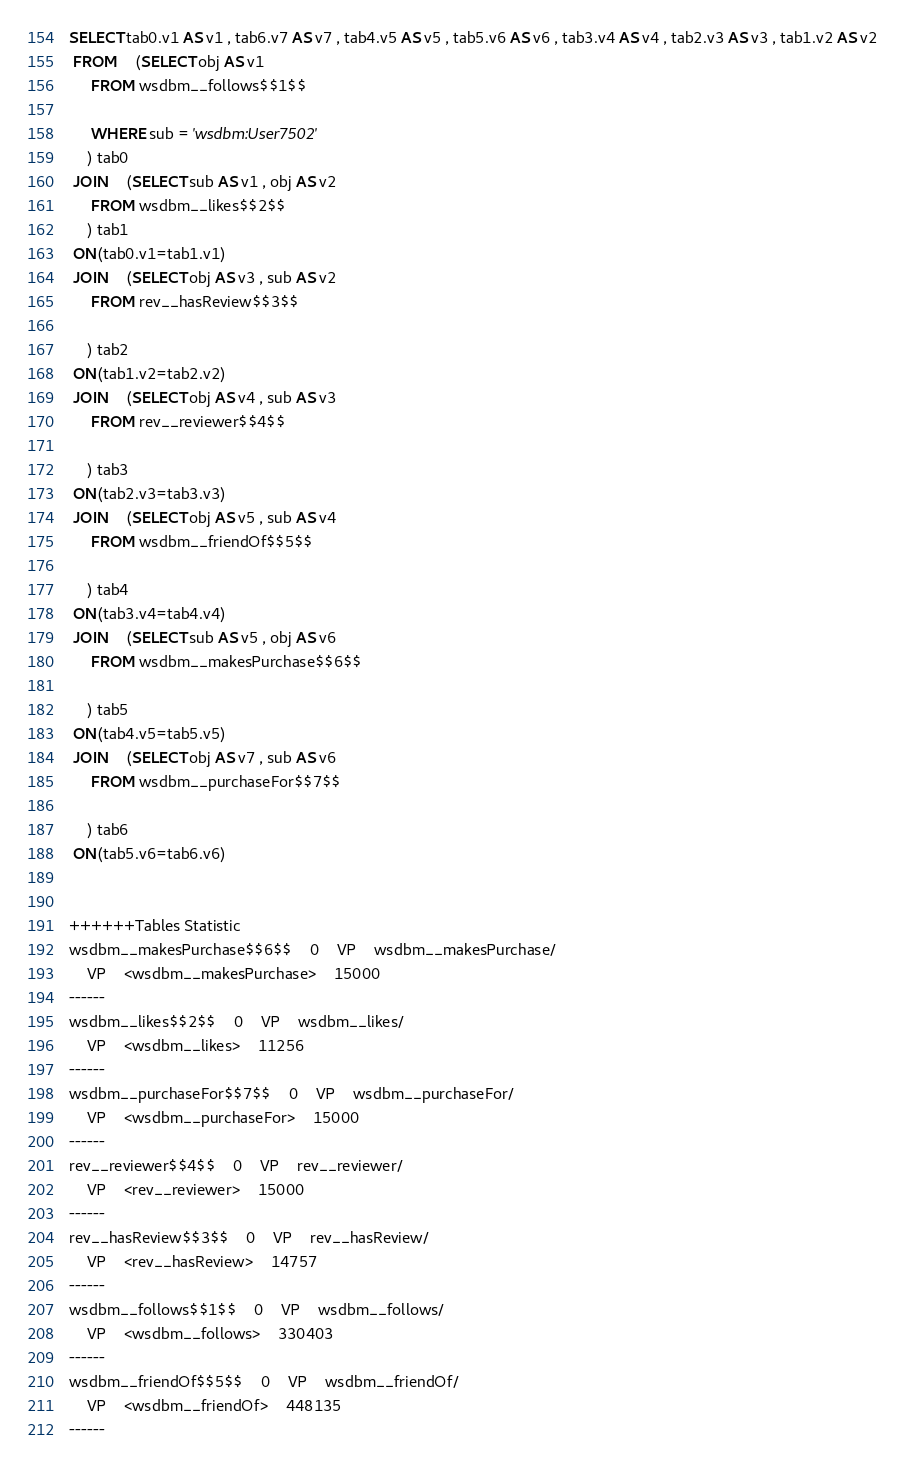Convert code to text. <code><loc_0><loc_0><loc_500><loc_500><_SQL_>SELECT tab0.v1 AS v1 , tab6.v7 AS v7 , tab4.v5 AS v5 , tab5.v6 AS v6 , tab3.v4 AS v4 , tab2.v3 AS v3 , tab1.v2 AS v2 
 FROM    (SELECT obj AS v1 
	 FROM wsdbm__follows$$1$$
	 
	 WHERE sub = 'wsdbm:User7502'
	) tab0
 JOIN    (SELECT sub AS v1 , obj AS v2 
	 FROM wsdbm__likes$$2$$
	) tab1
 ON(tab0.v1=tab1.v1)
 JOIN    (SELECT obj AS v3 , sub AS v2 
	 FROM rev__hasReview$$3$$
	
	) tab2
 ON(tab1.v2=tab2.v2)
 JOIN    (SELECT obj AS v4 , sub AS v3 
	 FROM rev__reviewer$$4$$
	
	) tab3
 ON(tab2.v3=tab3.v3)
 JOIN    (SELECT obj AS v5 , sub AS v4 
	 FROM wsdbm__friendOf$$5$$
	
	) tab4
 ON(tab3.v4=tab4.v4)
 JOIN    (SELECT sub AS v5 , obj AS v6 
	 FROM wsdbm__makesPurchase$$6$$
	
	) tab5
 ON(tab4.v5=tab5.v5)
 JOIN    (SELECT obj AS v7 , sub AS v6 
	 FROM wsdbm__purchaseFor$$7$$
	
	) tab6
 ON(tab5.v6=tab6.v6)


++++++Tables Statistic
wsdbm__makesPurchase$$6$$	0	VP	wsdbm__makesPurchase/
	VP	<wsdbm__makesPurchase>	15000
------
wsdbm__likes$$2$$	0	VP	wsdbm__likes/
	VP	<wsdbm__likes>	11256
------
wsdbm__purchaseFor$$7$$	0	VP	wsdbm__purchaseFor/
	VP	<wsdbm__purchaseFor>	15000
------
rev__reviewer$$4$$	0	VP	rev__reviewer/
	VP	<rev__reviewer>	15000
------
rev__hasReview$$3$$	0	VP	rev__hasReview/
	VP	<rev__hasReview>	14757
------
wsdbm__follows$$1$$	0	VP	wsdbm__follows/
	VP	<wsdbm__follows>	330403
------
wsdbm__friendOf$$5$$	0	VP	wsdbm__friendOf/
	VP	<wsdbm__friendOf>	448135
------
</code> 